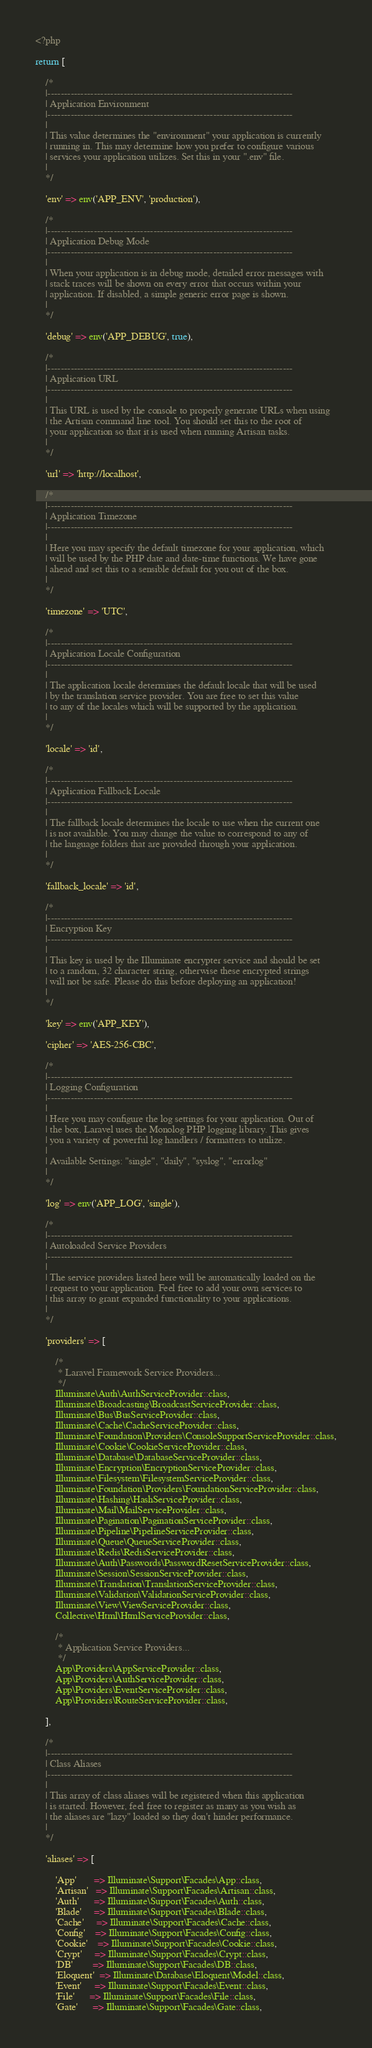Convert code to text. <code><loc_0><loc_0><loc_500><loc_500><_PHP_><?php

return [

    /*
    |--------------------------------------------------------------------------
    | Application Environment
    |--------------------------------------------------------------------------
    |
    | This value determines the "environment" your application is currently
    | running in. This may determine how you prefer to configure various
    | services your application utilizes. Set this in your ".env" file.
    |
    */

    'env' => env('APP_ENV', 'production'),

    /*
    |--------------------------------------------------------------------------
    | Application Debug Mode
    |--------------------------------------------------------------------------
    |
    | When your application is in debug mode, detailed error messages with
    | stack traces will be shown on every error that occurs within your
    | application. If disabled, a simple generic error page is shown.
    |
    */

    'debug' => env('APP_DEBUG', true),

    /*
    |--------------------------------------------------------------------------
    | Application URL
    |--------------------------------------------------------------------------
    |
    | This URL is used by the console to properly generate URLs when using
    | the Artisan command line tool. You should set this to the root of
    | your application so that it is used when running Artisan tasks.
    |
    */

    'url' => 'http://localhost',

    /*
    |--------------------------------------------------------------------------
    | Application Timezone
    |--------------------------------------------------------------------------
    |
    | Here you may specify the default timezone for your application, which
    | will be used by the PHP date and date-time functions. We have gone
    | ahead and set this to a sensible default for you out of the box.
    |
    */

    'timezone' => 'UTC',

    /*
    |--------------------------------------------------------------------------
    | Application Locale Configuration
    |--------------------------------------------------------------------------
    |
    | The application locale determines the default locale that will be used
    | by the translation service provider. You are free to set this value
    | to any of the locales which will be supported by the application.
    |
    */

    'locale' => 'id',

    /*
    |--------------------------------------------------------------------------
    | Application Fallback Locale
    |--------------------------------------------------------------------------
    |
    | The fallback locale determines the locale to use when the current one
    | is not available. You may change the value to correspond to any of
    | the language folders that are provided through your application.
    |
    */

    'fallback_locale' => 'id',

    /*
    |--------------------------------------------------------------------------
    | Encryption Key
    |--------------------------------------------------------------------------
    |
    | This key is used by the Illuminate encrypter service and should be set
    | to a random, 32 character string, otherwise these encrypted strings
    | will not be safe. Please do this before deploying an application!
    |
    */

    'key' => env('APP_KEY'),

    'cipher' => 'AES-256-CBC',

    /*
    |--------------------------------------------------------------------------
    | Logging Configuration
    |--------------------------------------------------------------------------
    |
    | Here you may configure the log settings for your application. Out of
    | the box, Laravel uses the Monolog PHP logging library. This gives
    | you a variety of powerful log handlers / formatters to utilize.
    |
    | Available Settings: "single", "daily", "syslog", "errorlog"
    |
    */

    'log' => env('APP_LOG', 'single'),

    /*
    |--------------------------------------------------------------------------
    | Autoloaded Service Providers
    |--------------------------------------------------------------------------
    |
    | The service providers listed here will be automatically loaded on the
    | request to your application. Feel free to add your own services to
    | this array to grant expanded functionality to your applications.
    |
    */

    'providers' => [

        /*
         * Laravel Framework Service Providers...
         */
        Illuminate\Auth\AuthServiceProvider::class,
        Illuminate\Broadcasting\BroadcastServiceProvider::class,
        Illuminate\Bus\BusServiceProvider::class,
        Illuminate\Cache\CacheServiceProvider::class,
        Illuminate\Foundation\Providers\ConsoleSupportServiceProvider::class,
        Illuminate\Cookie\CookieServiceProvider::class,
        Illuminate\Database\DatabaseServiceProvider::class,
        Illuminate\Encryption\EncryptionServiceProvider::class,
        Illuminate\Filesystem\FilesystemServiceProvider::class,
        Illuminate\Foundation\Providers\FoundationServiceProvider::class,
        Illuminate\Hashing\HashServiceProvider::class,
        Illuminate\Mail\MailServiceProvider::class,
        Illuminate\Pagination\PaginationServiceProvider::class,
        Illuminate\Pipeline\PipelineServiceProvider::class,
        Illuminate\Queue\QueueServiceProvider::class,
        Illuminate\Redis\RedisServiceProvider::class,
        Illuminate\Auth\Passwords\PasswordResetServiceProvider::class,
        Illuminate\Session\SessionServiceProvider::class,
        Illuminate\Translation\TranslationServiceProvider::class,
        Illuminate\Validation\ValidationServiceProvider::class,
        Illuminate\View\ViewServiceProvider::class,
        Collective\Html\HtmlServiceProvider::class,

        /*
         * Application Service Providers...
         */
        App\Providers\AppServiceProvider::class,
        App\Providers\AuthServiceProvider::class,
        App\Providers\EventServiceProvider::class,
        App\Providers\RouteServiceProvider::class,

    ],

    /*
    |--------------------------------------------------------------------------
    | Class Aliases
    |--------------------------------------------------------------------------
    |
    | This array of class aliases will be registered when this application
    | is started. However, feel free to register as many as you wish as
    | the aliases are "lazy" loaded so they don't hinder performance.
    |
    */

    'aliases' => [

        'App'       => Illuminate\Support\Facades\App::class,
        'Artisan'   => Illuminate\Support\Facades\Artisan::class,
        'Auth'      => Illuminate\Support\Facades\Auth::class,
        'Blade'     => Illuminate\Support\Facades\Blade::class,
        'Cache'     => Illuminate\Support\Facades\Cache::class,
        'Config'    => Illuminate\Support\Facades\Config::class,
        'Cookie'    => Illuminate\Support\Facades\Cookie::class,
        'Crypt'     => Illuminate\Support\Facades\Crypt::class,
        'DB'        => Illuminate\Support\Facades\DB::class,
        'Eloquent'  => Illuminate\Database\Eloquent\Model::class,
        'Event'     => Illuminate\Support\Facades\Event::class,
        'File'      => Illuminate\Support\Facades\File::class,
        'Gate'      => Illuminate\Support\Facades\Gate::class,</code> 